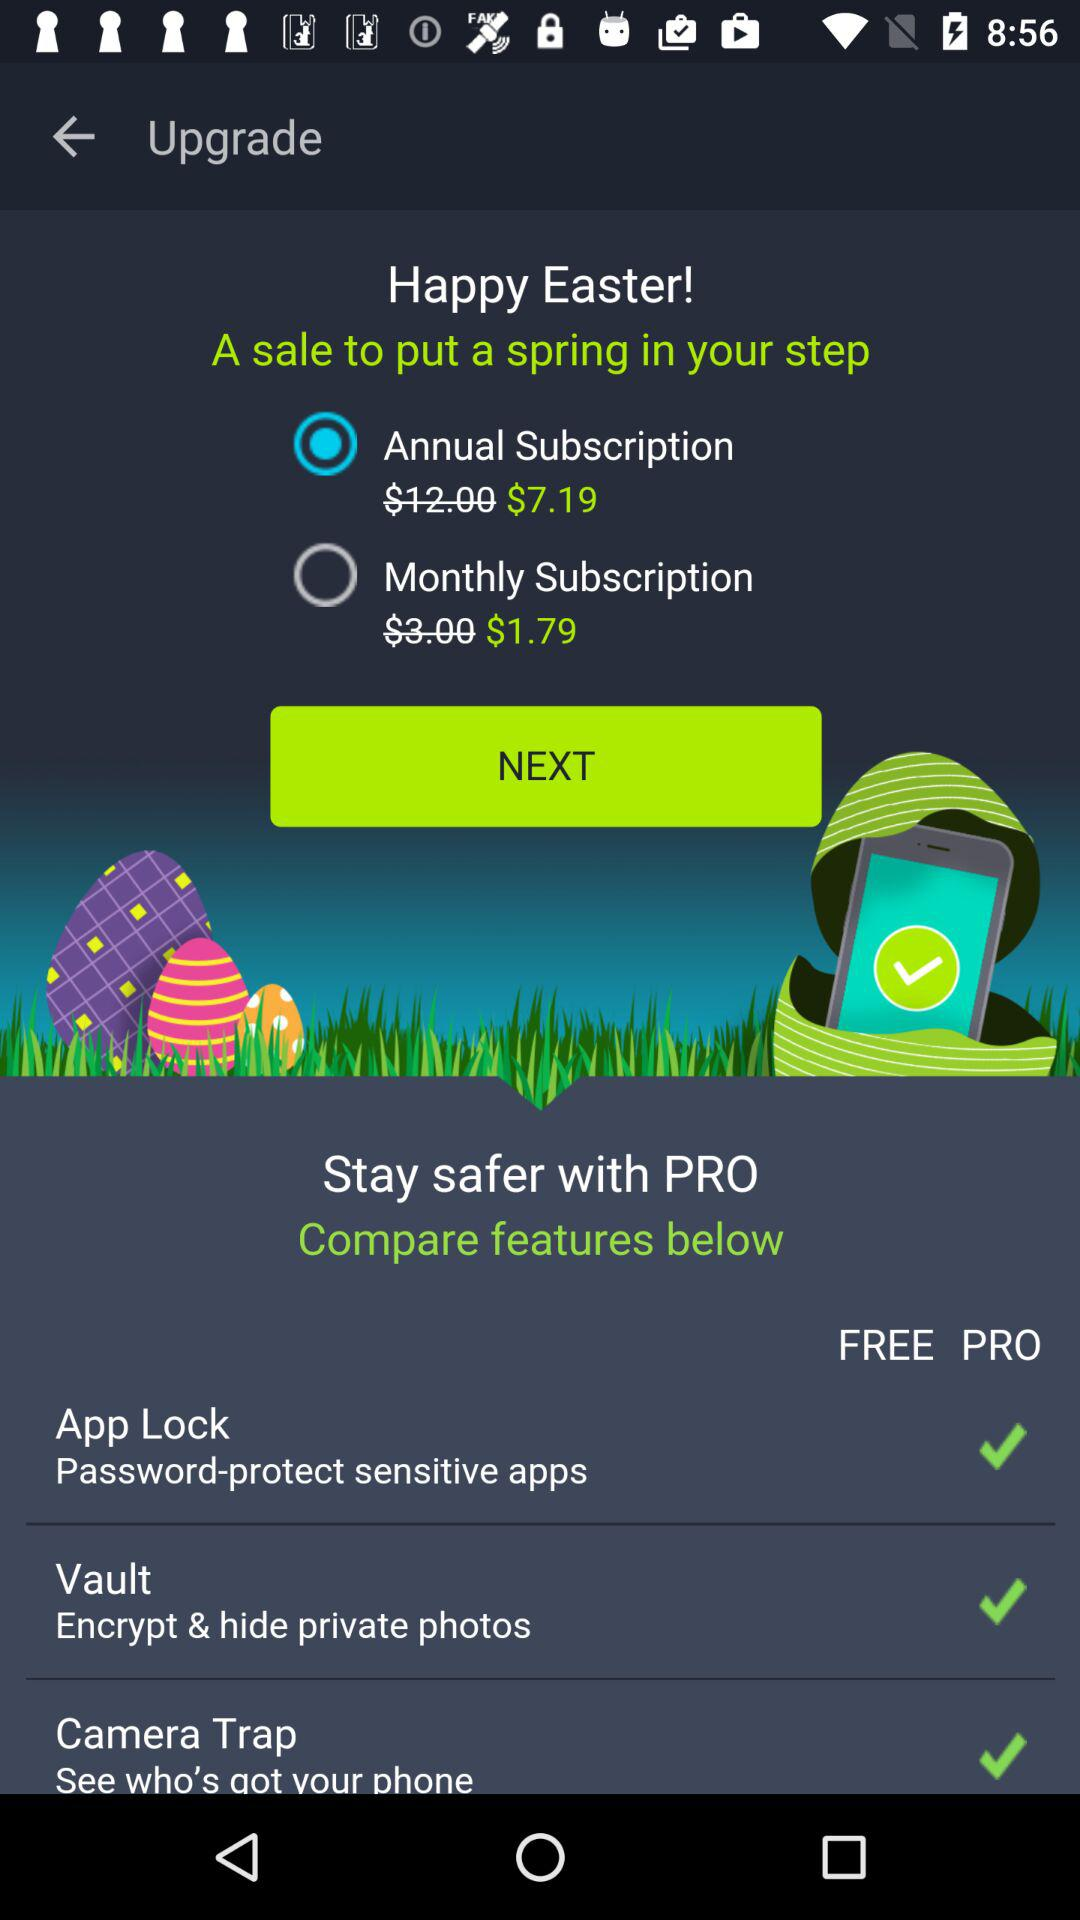What is the cost of the monthly subscription? The cost of the monthly subscription is $1.79. 